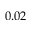Convert formula to latex. <formula><loc_0><loc_0><loc_500><loc_500>0 . 0 2</formula> 